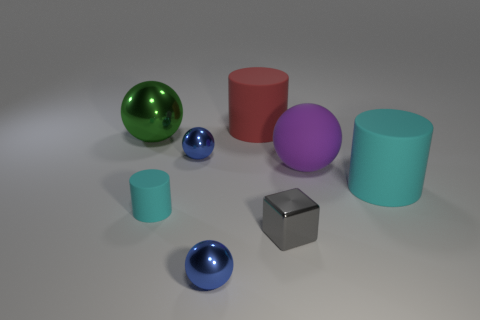There is a matte cylinder that is the same color as the small rubber object; what size is it?
Provide a short and direct response. Large. How many big rubber cylinders have the same color as the small cylinder?
Your answer should be compact. 1. There is a matte object behind the green sphere; what shape is it?
Your answer should be compact. Cylinder. What color is the matte ball that is the same size as the green metal sphere?
Your response must be concise. Purple. Do the large cylinder in front of the red matte object and the gray thing have the same material?
Make the answer very short. No. What size is the metallic sphere that is in front of the green metallic sphere and behind the gray object?
Provide a succinct answer. Small. There is a cylinder behind the large green thing; how big is it?
Offer a very short reply. Large. The other object that is the same color as the tiny matte thing is what shape?
Make the answer very short. Cylinder. There is a small shiny object to the left of the ball in front of the big cyan object that is right of the tiny gray metal cube; what is its shape?
Ensure brevity in your answer.  Sphere. How many other things are there of the same shape as the large red rubber object?
Give a very brief answer. 2. 